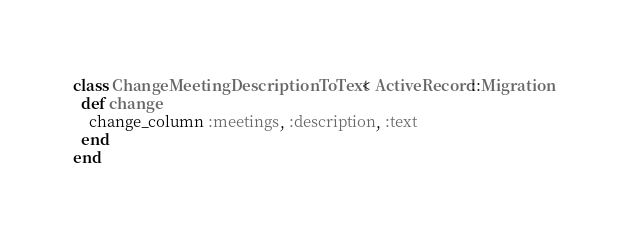<code> <loc_0><loc_0><loc_500><loc_500><_Ruby_>class ChangeMeetingDescriptionToText < ActiveRecord::Migration
  def change
    change_column :meetings, :description, :text
  end
end
</code> 